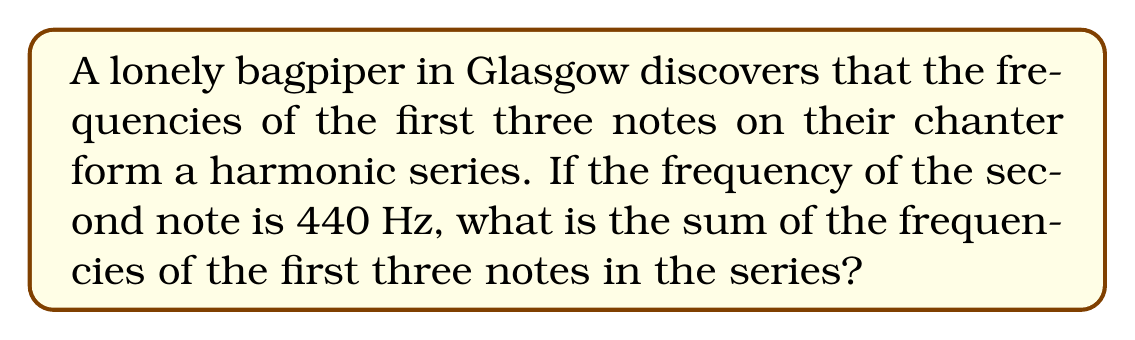Can you solve this math problem? Let's approach this step-by-step:

1) In a harmonic series, each term is the reciprocal of an integer multiple of a fundamental frequency. If we denote the fundamental frequency as $f$, the series would be:

   $$f, 2f, 3f, 4f, ...$$

2) We're told that the second note has a frequency of 440 Hz. In our harmonic series, this corresponds to $2f$. So:

   $$2f = 440 \text{ Hz}$$

3) Solving for $f$:

   $$f = 440 / 2 = 220 \text{ Hz}$$

4) Now we can calculate the frequencies of the first three notes:
   - First note: $f = 220 \text{ Hz}$
   - Second note: $2f = 440 \text{ Hz}$
   - Third note: $3f = 3 * 220 = 660 \text{ Hz}$

5) The sum of these frequencies is:

   $$220 + 440 + 660 = 1320 \text{ Hz}$$
Answer: 1320 Hz 